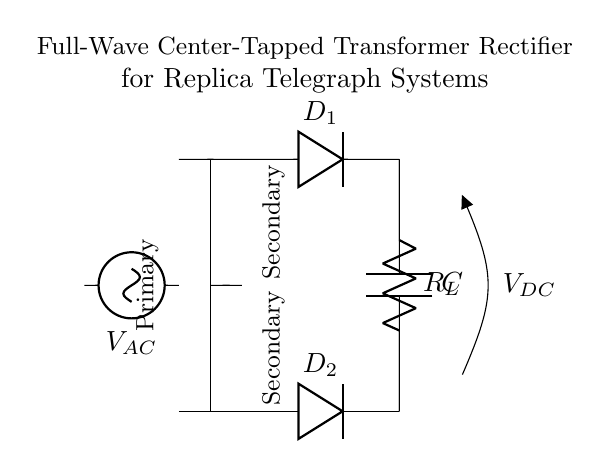What is the type of the rectifier circuit shown? The circuit is a full-wave center-tapped transformer rectifier because it uses a center-tapped transformer and two diodes to rectify both halves of the AC input.
Answer: full-wave center-tapped transformer rectifier How many diodes are used in this circuit? There are two diodes in this circuit, labeled as D1 and D2. They are responsible for rectifying the AC signal.
Answer: two What component provides the DC voltage output? The output DC voltage is provided by the load resistor labeled as R_L, connected in parallel to the smoothing capacitor C.
Answer: load resistor What is the purpose of the capacitor in this circuit? The capacitor labeled as C serves to smooth the output DC voltage by reducing voltage ripples, providing a more stable DC supply for the load.
Answer: smoothing What is the function of the transformer in this circuit? The transformer steps down the AC voltage from the source to a suitable level for the diodes to rectify and supply to the load.
Answer: step-down voltage How is the AC voltage applied to the diodes? The AC voltage from the source is applied to the center-tap of the transformer, which then connects to the two diodes at their respective anodes, allowing both halves of the AC waveform to be utilized.
Answer: center-tap connection What is the output voltage labeled as in the circuit? The output voltage is labeled as V_DC, indicating the direct current voltage produced after rectification and smoothing by the circuit.
Answer: V_DC 